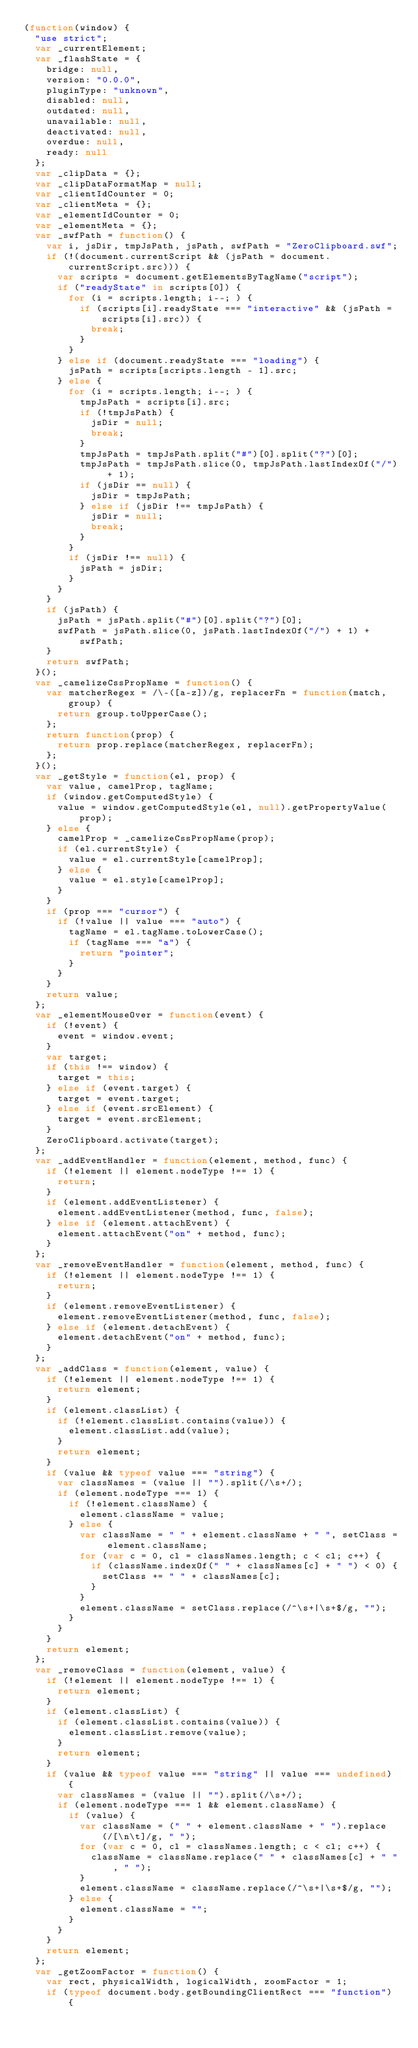Convert code to text. <code><loc_0><loc_0><loc_500><loc_500><_JavaScript_>(function(window) {
  "use strict";
  var _currentElement;
  var _flashState = {
    bridge: null,
    version: "0.0.0",
    pluginType: "unknown",
    disabled: null,
    outdated: null,
    unavailable: null,
    deactivated: null,
    overdue: null,
    ready: null
  };
  var _clipData = {};
  var _clipDataFormatMap = null;
  var _clientIdCounter = 0;
  var _clientMeta = {};
  var _elementIdCounter = 0;
  var _elementMeta = {};
  var _swfPath = function() {
    var i, jsDir, tmpJsPath, jsPath, swfPath = "ZeroClipboard.swf";
    if (!(document.currentScript && (jsPath = document.currentScript.src))) {
      var scripts = document.getElementsByTagName("script");
      if ("readyState" in scripts[0]) {
        for (i = scripts.length; i--; ) {
          if (scripts[i].readyState === "interactive" && (jsPath = scripts[i].src)) {
            break;
          }
        }
      } else if (document.readyState === "loading") {
        jsPath = scripts[scripts.length - 1].src;
      } else {
        for (i = scripts.length; i--; ) {
          tmpJsPath = scripts[i].src;
          if (!tmpJsPath) {
            jsDir = null;
            break;
          }
          tmpJsPath = tmpJsPath.split("#")[0].split("?")[0];
          tmpJsPath = tmpJsPath.slice(0, tmpJsPath.lastIndexOf("/") + 1);
          if (jsDir == null) {
            jsDir = tmpJsPath;
          } else if (jsDir !== tmpJsPath) {
            jsDir = null;
            break;
          }
        }
        if (jsDir !== null) {
          jsPath = jsDir;
        }
      }
    }
    if (jsPath) {
      jsPath = jsPath.split("#")[0].split("?")[0];
      swfPath = jsPath.slice(0, jsPath.lastIndexOf("/") + 1) + swfPath;
    }
    return swfPath;
  }();
  var _camelizeCssPropName = function() {
    var matcherRegex = /\-([a-z])/g, replacerFn = function(match, group) {
      return group.toUpperCase();
    };
    return function(prop) {
      return prop.replace(matcherRegex, replacerFn);
    };
  }();
  var _getStyle = function(el, prop) {
    var value, camelProp, tagName;
    if (window.getComputedStyle) {
      value = window.getComputedStyle(el, null).getPropertyValue(prop);
    } else {
      camelProp = _camelizeCssPropName(prop);
      if (el.currentStyle) {
        value = el.currentStyle[camelProp];
      } else {
        value = el.style[camelProp];
      }
    }
    if (prop === "cursor") {
      if (!value || value === "auto") {
        tagName = el.tagName.toLowerCase();
        if (tagName === "a") {
          return "pointer";
        }
      }
    }
    return value;
  };
  var _elementMouseOver = function(event) {
    if (!event) {
      event = window.event;
    }
    var target;
    if (this !== window) {
      target = this;
    } else if (event.target) {
      target = event.target;
    } else if (event.srcElement) {
      target = event.srcElement;
    }
    ZeroClipboard.activate(target);
  };
  var _addEventHandler = function(element, method, func) {
    if (!element || element.nodeType !== 1) {
      return;
    }
    if (element.addEventListener) {
      element.addEventListener(method, func, false);
    } else if (element.attachEvent) {
      element.attachEvent("on" + method, func);
    }
  };
  var _removeEventHandler = function(element, method, func) {
    if (!element || element.nodeType !== 1) {
      return;
    }
    if (element.removeEventListener) {
      element.removeEventListener(method, func, false);
    } else if (element.detachEvent) {
      element.detachEvent("on" + method, func);
    }
  };
  var _addClass = function(element, value) {
    if (!element || element.nodeType !== 1) {
      return element;
    }
    if (element.classList) {
      if (!element.classList.contains(value)) {
        element.classList.add(value);
      }
      return element;
    }
    if (value && typeof value === "string") {
      var classNames = (value || "").split(/\s+/);
      if (element.nodeType === 1) {
        if (!element.className) {
          element.className = value;
        } else {
          var className = " " + element.className + " ", setClass = element.className;
          for (var c = 0, cl = classNames.length; c < cl; c++) {
            if (className.indexOf(" " + classNames[c] + " ") < 0) {
              setClass += " " + classNames[c];
            }
          }
          element.className = setClass.replace(/^\s+|\s+$/g, "");
        }
      }
    }
    return element;
  };
  var _removeClass = function(element, value) {
    if (!element || element.nodeType !== 1) {
      return element;
    }
    if (element.classList) {
      if (element.classList.contains(value)) {
        element.classList.remove(value);
      }
      return element;
    }
    if (value && typeof value === "string" || value === undefined) {
      var classNames = (value || "").split(/\s+/);
      if (element.nodeType === 1 && element.className) {
        if (value) {
          var className = (" " + element.className + " ").replace(/[\n\t]/g, " ");
          for (var c = 0, cl = classNames.length; c < cl; c++) {
            className = className.replace(" " + classNames[c] + " ", " ");
          }
          element.className = className.replace(/^\s+|\s+$/g, "");
        } else {
          element.className = "";
        }
      }
    }
    return element;
  };
  var _getZoomFactor = function() {
    var rect, physicalWidth, logicalWidth, zoomFactor = 1;
    if (typeof document.body.getBoundingClientRect === "function") {</code> 